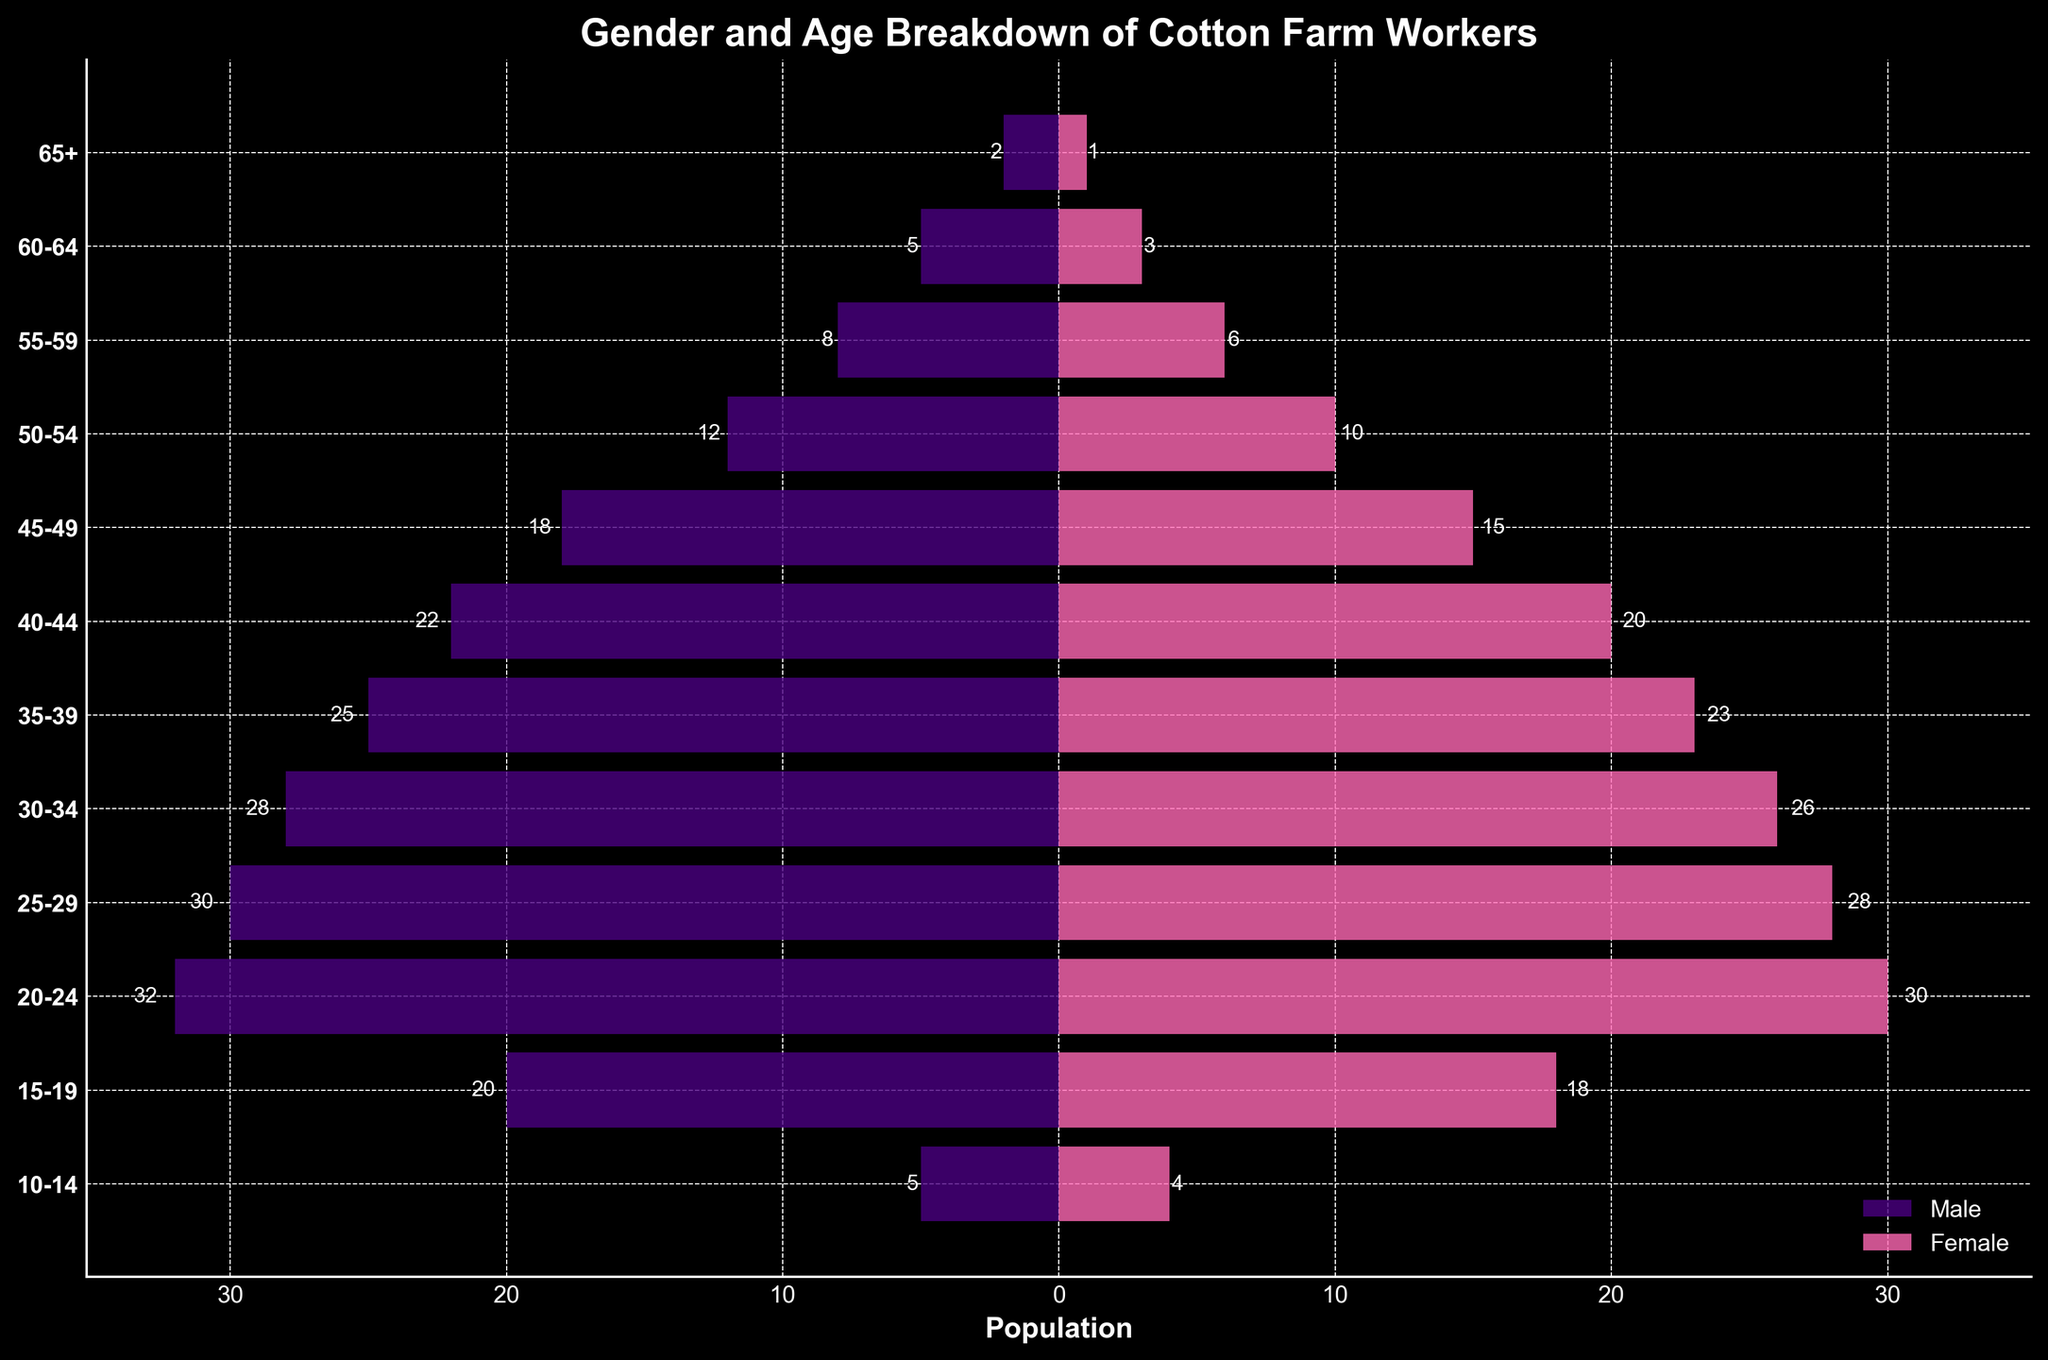What is the title of the figure? The title of the figure is usually located at the top and gives an overview of what the visual is displaying. In this case, the title "Gender and Age Breakdown of Cotton Farm Workers" describes the demographic distribution.
Answer: Gender and Age Breakdown of Cotton Farm Workers Which age group has the highest number of male workers? To determine the age group with the highest number of male workers, look at the lengths of the bars on the left side of the chart. The longest bar corresponds to the age group 20-24 with 32 male workers.
Answer: 20-24 How many total female workers are there in the age groups 25-29 and 30-34? Add the number of female workers in the age group 25-29 (28) to those in the age group 30-34 (26). 28 + 26 = 54.
Answer: 54 What is the difference in the number of male and female workers in the age group 40-44? Subtract the number of female workers in the age group 40-44 (20) from the number of male workers (22). 22 - 20 = 2.
Answer: 2 In which age group is the male-to-female ratio the highest? To find the age group with the highest male-to-female ratio, divide the number of males by the number of females for each age group. The age group 10-14 has a male-to-female ratio of 5:4 which simplifies to 1.25, the highest ratio observed.
Answer: 10-14 How many age groups have more male workers than female workers? Count the age groups where the bar representing male workers is longer than the bar representing female workers. These groups are 60-64, 55-59, 50-54, 45-49, 40-44, 35-39, 30-34, 25-29, 20-24, and 10-14.
Answer: 10 What is the total number of male workers across all age groups? Add the number of male workers in each age group: 2 + 5 + 8 + 12 + 18 + 22 + 25 + 28 + 30 + 32 + 20 + 5 = 207.
Answer: 207 Which age group has the closest number of male and female workers? To find the closest numbers, look at the differences between males and females in each group. The age group 40-44 has 22 males and 20 females, resulting in a difference of 2, the smallest observed.
Answer: 40-44 Are there any age groups where the number of male and female workers is equal? Compare the numbers of male and female workers in each age group. No age groups have an equal number of male and female workers.
Answer: No 